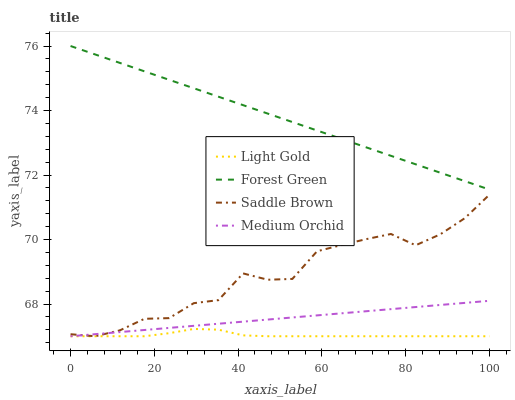Does Medium Orchid have the minimum area under the curve?
Answer yes or no. No. Does Medium Orchid have the maximum area under the curve?
Answer yes or no. No. Is Medium Orchid the smoothest?
Answer yes or no. No. Is Medium Orchid the roughest?
Answer yes or no. No. Does Medium Orchid have the highest value?
Answer yes or no. No. Is Medium Orchid less than Forest Green?
Answer yes or no. Yes. Is Forest Green greater than Light Gold?
Answer yes or no. Yes. Does Medium Orchid intersect Forest Green?
Answer yes or no. No. 